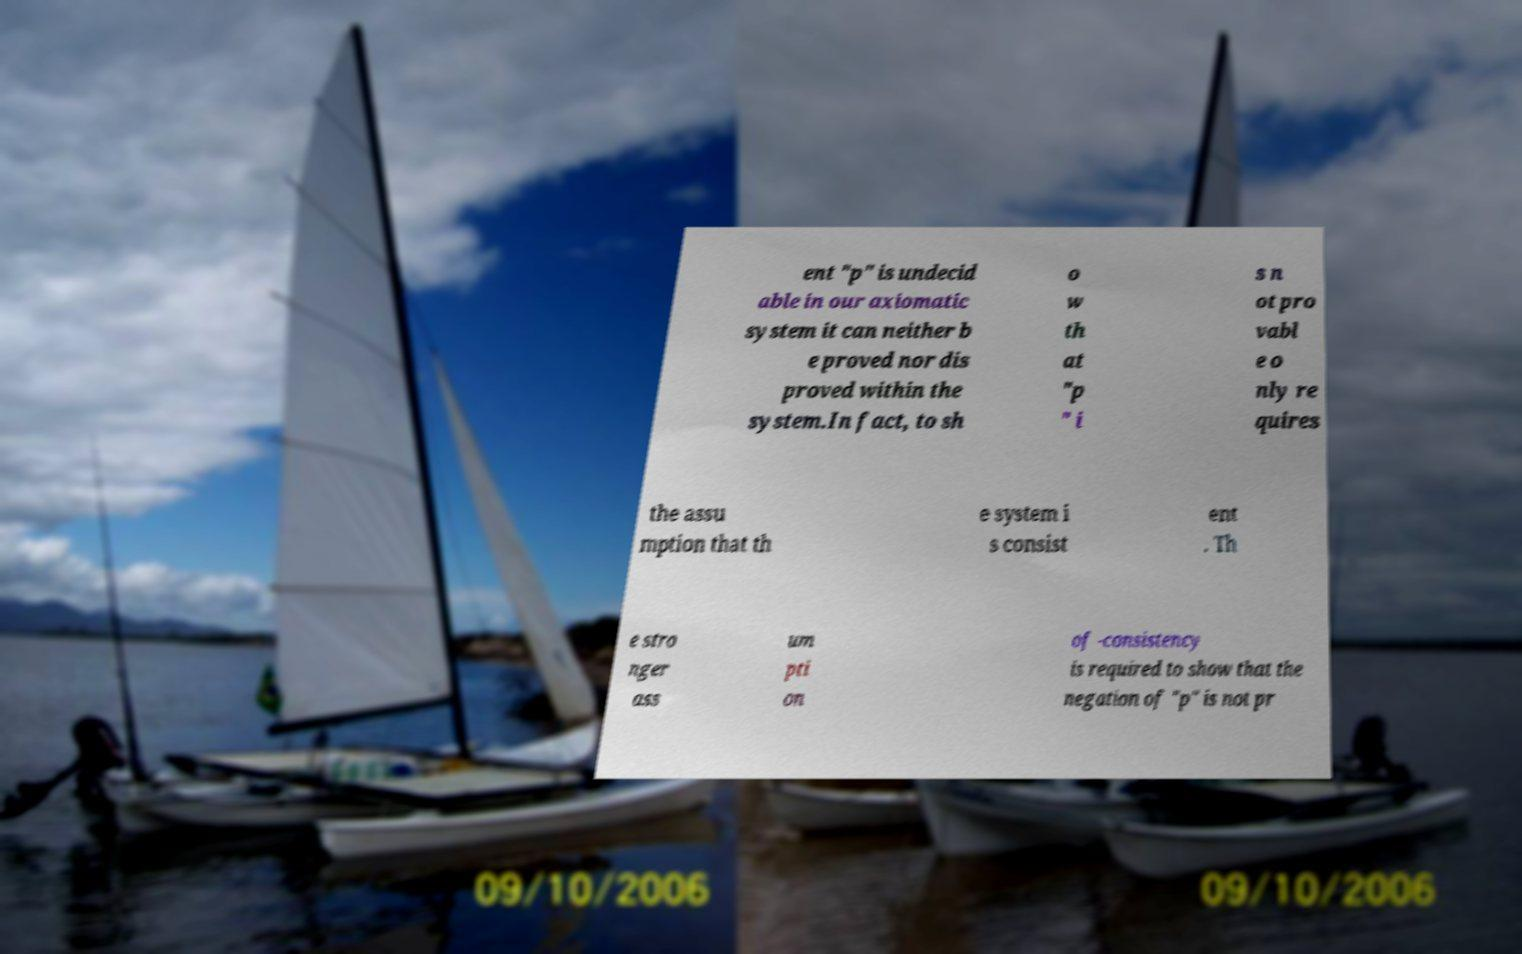There's text embedded in this image that I need extracted. Can you transcribe it verbatim? ent "p" is undecid able in our axiomatic system it can neither b e proved nor dis proved within the system.In fact, to sh o w th at "p " i s n ot pro vabl e o nly re quires the assu mption that th e system i s consist ent . Th e stro nger ass um pti on of -consistency is required to show that the negation of "p" is not pr 